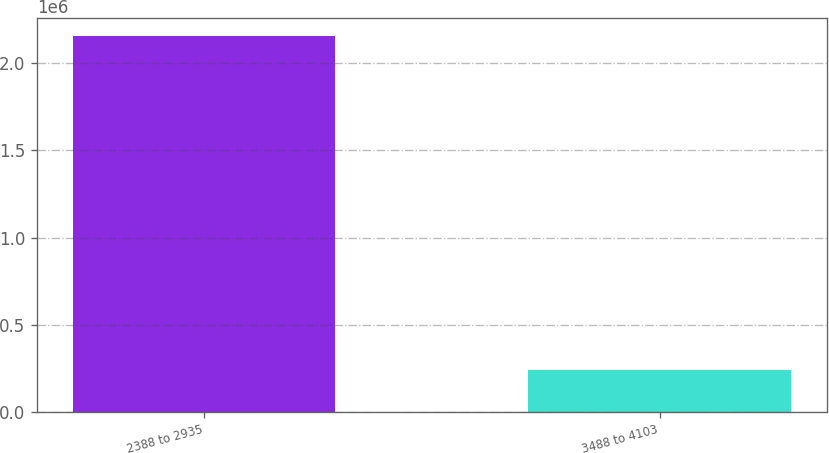<chart> <loc_0><loc_0><loc_500><loc_500><bar_chart><fcel>2388 to 2935<fcel>3488 to 4103<nl><fcel>2.15351e+06<fcel>238755<nl></chart> 